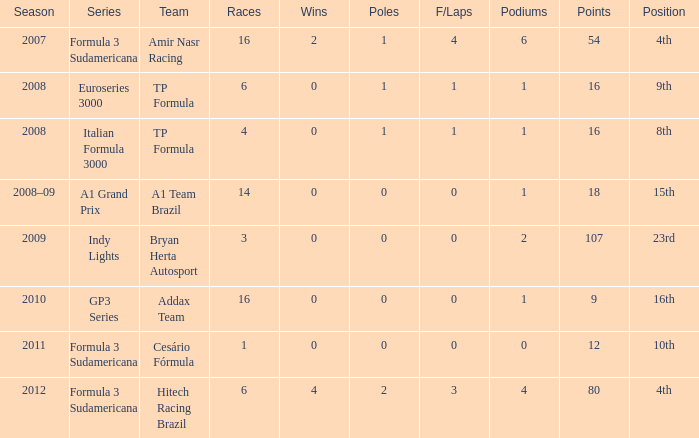Could you parse the entire table as a dict? {'header': ['Season', 'Series', 'Team', 'Races', 'Wins', 'Poles', 'F/Laps', 'Podiums', 'Points', 'Position'], 'rows': [['2007', 'Formula 3 Sudamericana', 'Amir Nasr Racing', '16', '2', '1', '4', '6', '54', '4th'], ['2008', 'Euroseries 3000', 'TP Formula', '6', '0', '1', '1', '1', '16', '9th'], ['2008', 'Italian Formula 3000', 'TP Formula', '4', '0', '1', '1', '1', '16', '8th'], ['2008–09', 'A1 Grand Prix', 'A1 Team Brazil', '14', '0', '0', '0', '1', '18', '15th'], ['2009', 'Indy Lights', 'Bryan Herta Autosport', '3', '0', '0', '0', '2', '107', '23rd'], ['2010', 'GP3 Series', 'Addax Team', '16', '0', '0', '0', '1', '9', '16th'], ['2011', 'Formula 3 Sudamericana', 'Cesário Fórmula', '1', '0', '0', '0', '0', '12', '10th'], ['2012', 'Formula 3 Sudamericana', 'Hitech Racing Brazil', '6', '4', '2', '3', '4', '80', '4th']]} How many points were awarded to him for the race in which he had more than 1.0 poles? 80.0. 